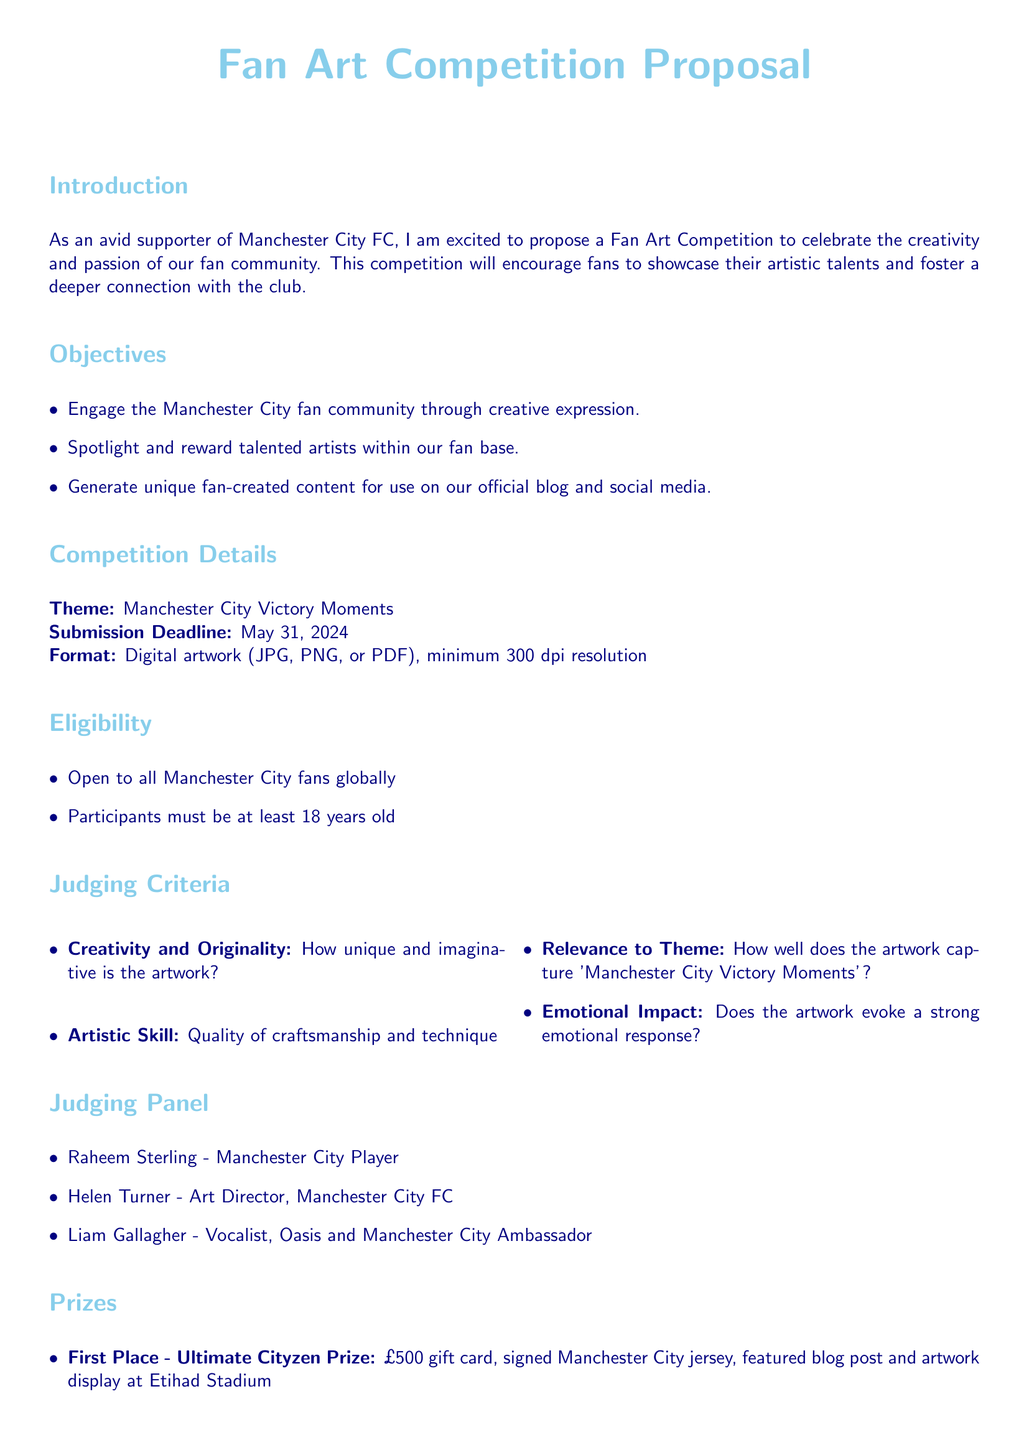What is the title of the proposal? The title of the proposal is located at the top of the document.
Answer: Fan Art Competition Proposal What is the competition theme? The theme is mentioned in the Competition Details section of the document.
Answer: Manchester City Victory Moments What is the submission deadline? The submission deadline is specified in the Competition Details section.
Answer: May 31, 2024 How many judges are there on the panel? The number of judges is listed under the Judging Panel section.
Answer: Three What prize does the first place winner receive? The prize for first place is detailed in the Prizes section of the document.
Answer: £500 gift card, signed Manchester City jersey, featured blog post and artwork display at Etihad Stadium What is one of the judging criteria for the competition? One of the criteria is noted in the Judging Criteria section.
Answer: Creativity and Originality Who is a member of the judging panel? A member of the judging panel is identified in the Judging Panel section.
Answer: Raheem Sterling What is the minimum submission resolution? The required submission resolution is stated in Competition Details.
Answer: 300 dpi Are there age restrictions to participate in the competition? Age restrictions are mentioned in the Eligibility section.
Answer: Yes, participants must be at least 18 years old 